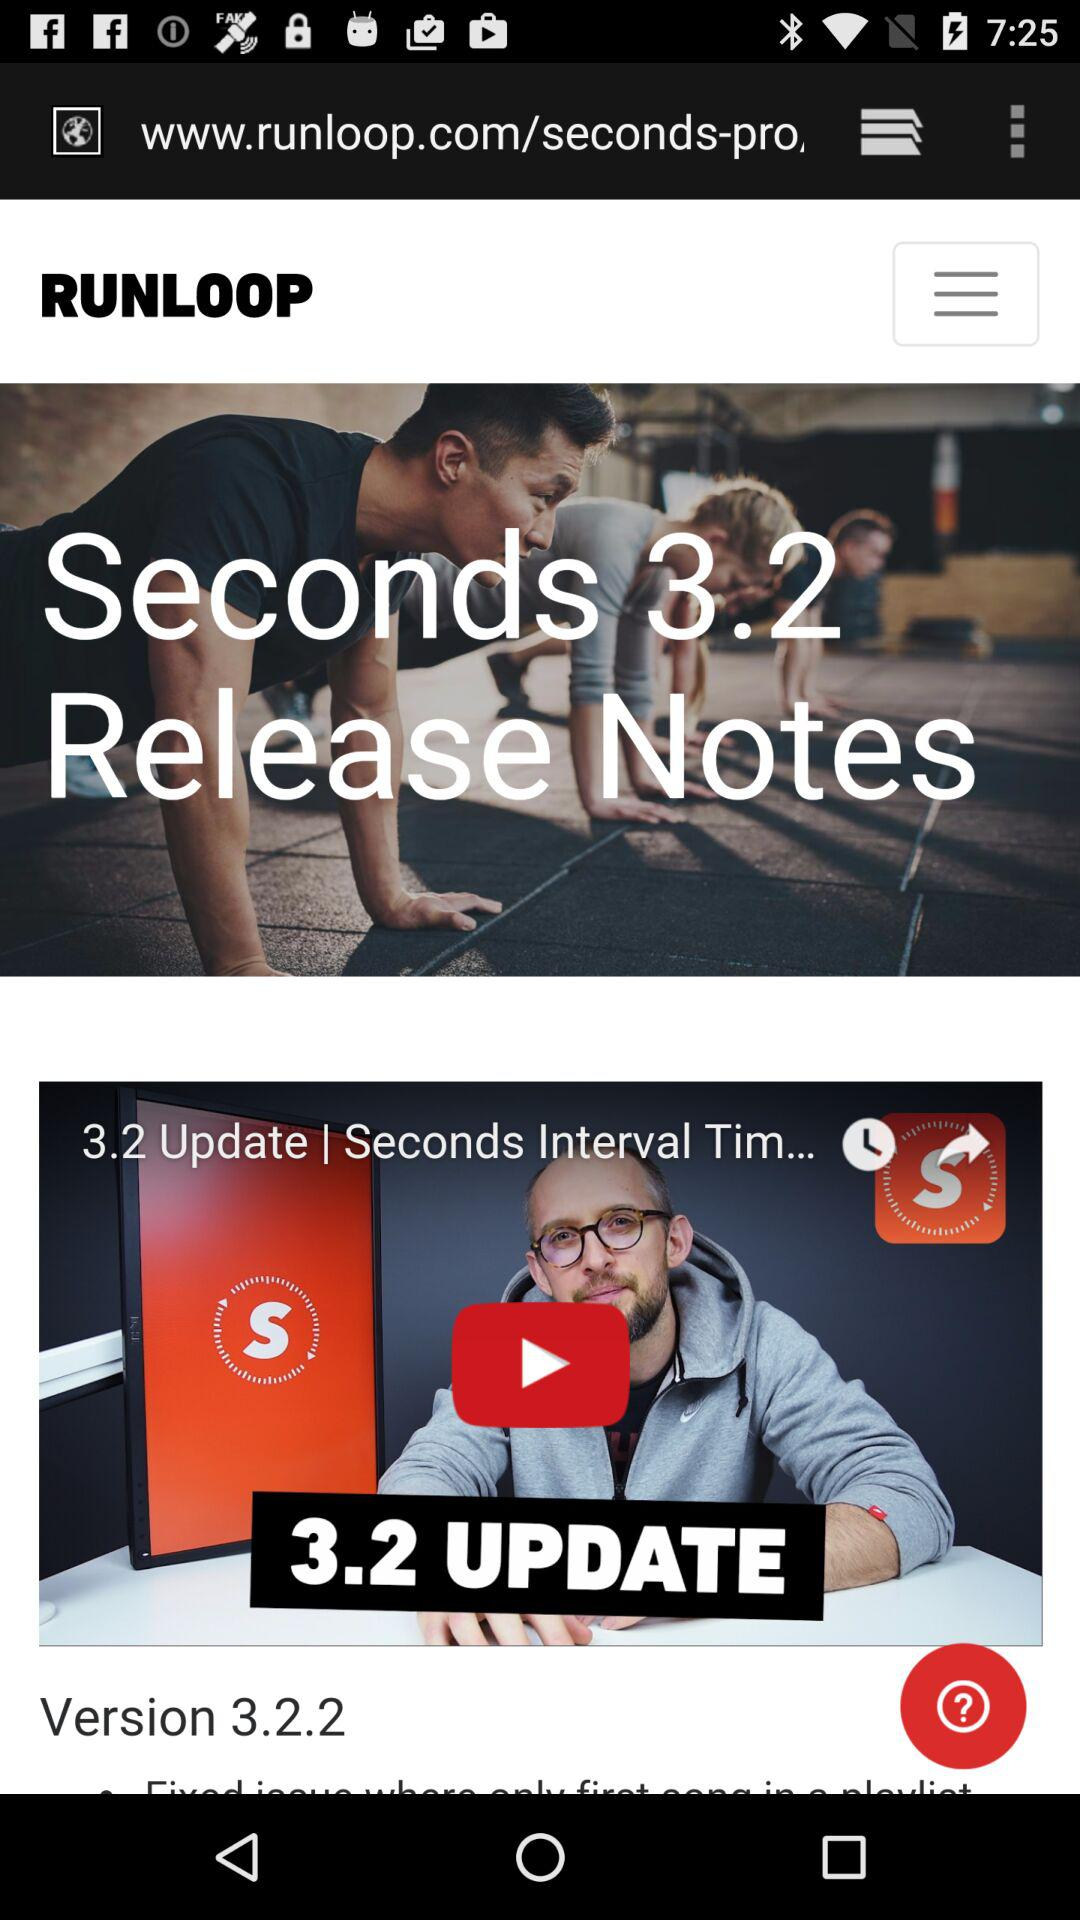What's the title of the video? The title of the video is "3.2 Update | Seconds Interval Tim...". 